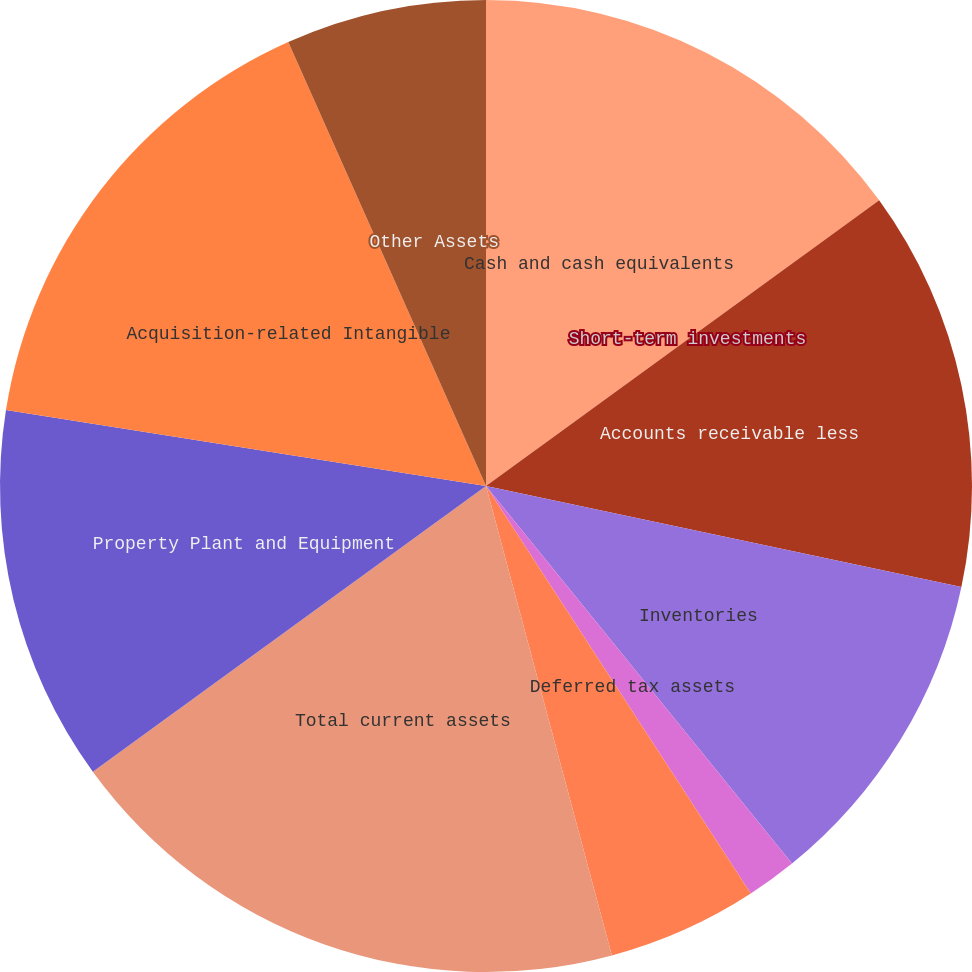Convert chart to OTSL. <chart><loc_0><loc_0><loc_500><loc_500><pie_chart><fcel>Cash and cash equivalents<fcel>Short-term investments<fcel>Accounts receivable less<fcel>Inventories<fcel>Deferred tax assets<fcel>Other current assets<fcel>Total current assets<fcel>Property Plant and Equipment<fcel>Acquisition-related Intangible<fcel>Other Assets<nl><fcel>15.0%<fcel>0.0%<fcel>13.33%<fcel>10.83%<fcel>1.67%<fcel>5.0%<fcel>19.17%<fcel>12.5%<fcel>15.83%<fcel>6.67%<nl></chart> 